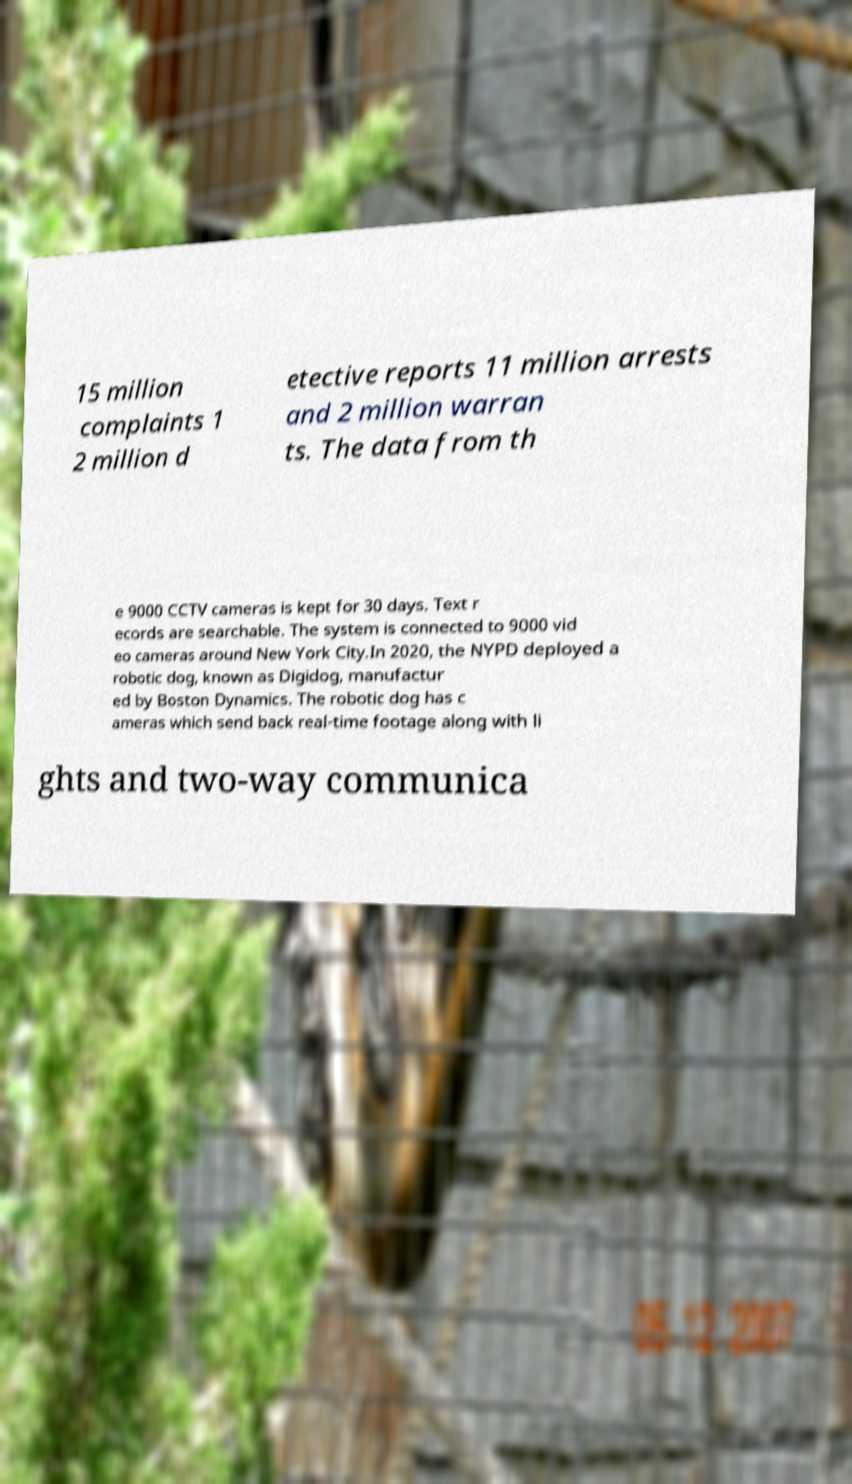Can you read and provide the text displayed in the image?This photo seems to have some interesting text. Can you extract and type it out for me? 15 million complaints 1 2 million d etective reports 11 million arrests and 2 million warran ts. The data from th e 9000 CCTV cameras is kept for 30 days. Text r ecords are searchable. The system is connected to 9000 vid eo cameras around New York City.In 2020, the NYPD deployed a robotic dog, known as Digidog, manufactur ed by Boston Dynamics. The robotic dog has c ameras which send back real-time footage along with li ghts and two-way communica 